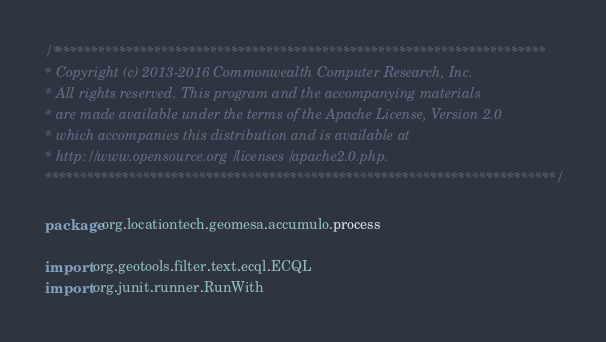<code> <loc_0><loc_0><loc_500><loc_500><_Scala_>/***********************************************************************
* Copyright (c) 2013-2016 Commonwealth Computer Research, Inc.
* All rights reserved. This program and the accompanying materials
* are made available under the terms of the Apache License, Version 2.0
* which accompanies this distribution and is available at
* http://www.opensource.org/licenses/apache2.0.php.
*************************************************************************/

package org.locationtech.geomesa.accumulo.process

import org.geotools.filter.text.ecql.ECQL
import org.junit.runner.RunWith</code> 